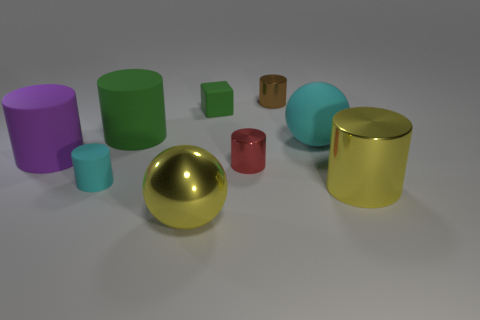How many large cyan matte things are there?
Offer a very short reply. 1. There is a big object that is the same material as the big yellow ball; what color is it?
Ensure brevity in your answer.  Yellow. Is the number of big metal cylinders greater than the number of yellow objects?
Your answer should be very brief. No. What is the size of the object that is behind the large cyan ball and to the left of the tiny green object?
Make the answer very short. Large. There is a thing that is the same color as the small matte cylinder; what material is it?
Provide a short and direct response. Rubber. Are there an equal number of small brown shiny cylinders that are left of the red metal cylinder and large brown rubber balls?
Offer a terse response. Yes. Is the size of the rubber ball the same as the red metal thing?
Ensure brevity in your answer.  No. What is the color of the large cylinder that is on the left side of the brown cylinder and to the right of the purple cylinder?
Offer a very short reply. Green. What is the material of the thing that is in front of the shiny cylinder in front of the small cyan object?
Offer a terse response. Metal. What size is the red metallic object that is the same shape as the big purple rubber thing?
Offer a very short reply. Small. 